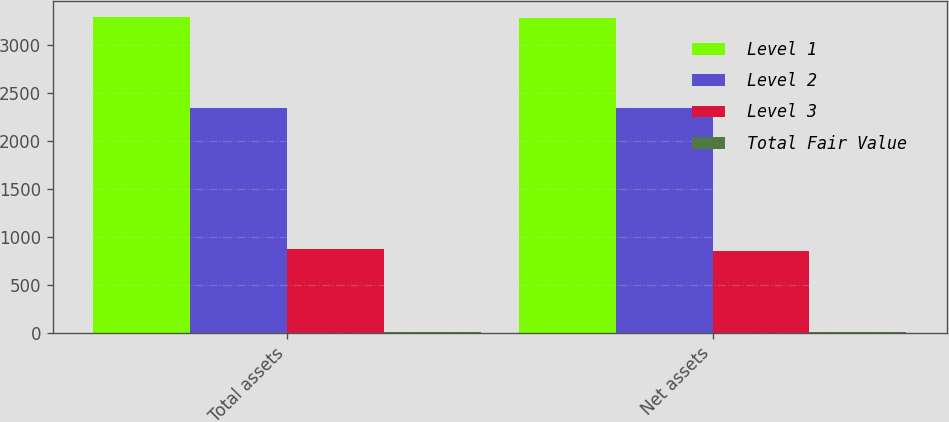<chart> <loc_0><loc_0><loc_500><loc_500><stacked_bar_chart><ecel><fcel>Total assets<fcel>Net assets<nl><fcel>Level 1<fcel>3294<fcel>3278<nl><fcel>Level 2<fcel>2346<fcel>2346<nl><fcel>Level 3<fcel>868<fcel>852<nl><fcel>Total Fair Value<fcel>3<fcel>3<nl></chart> 